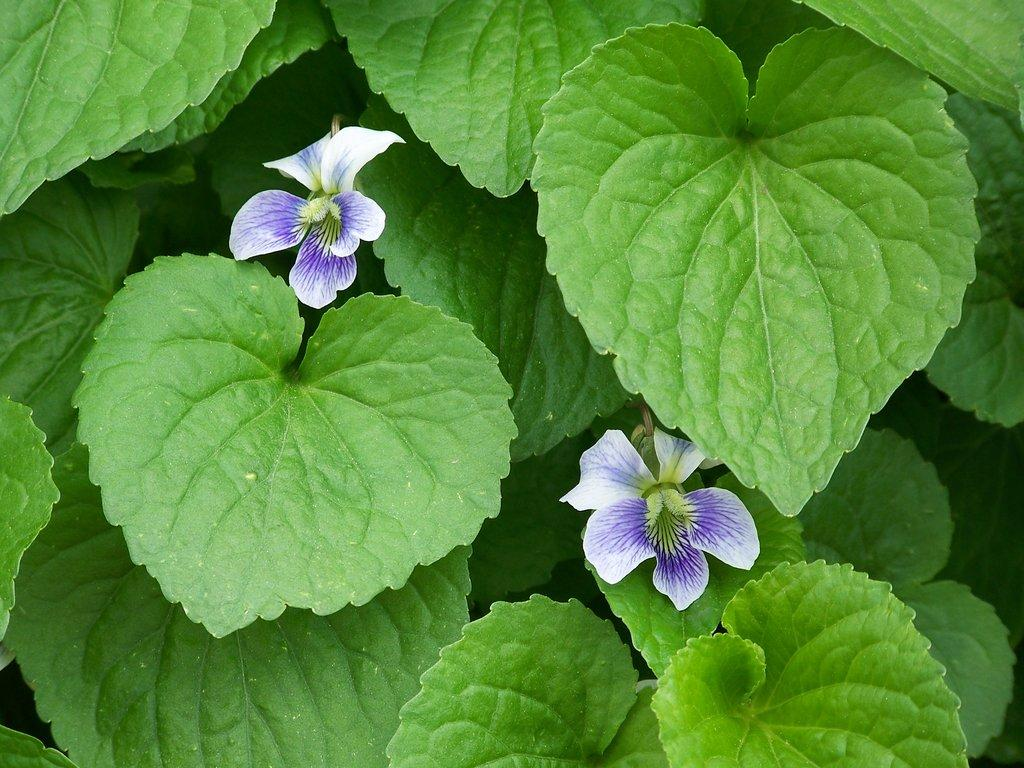What type of vegetation is present in the image? There are green leaves in the image. How many flowers can be seen in the image? There are two flowers in the image. Can you see a bee buzzing around the flowers in the image? There is no bee present in the image. Is there a bag visible in the image? There is no bag present in the image. 